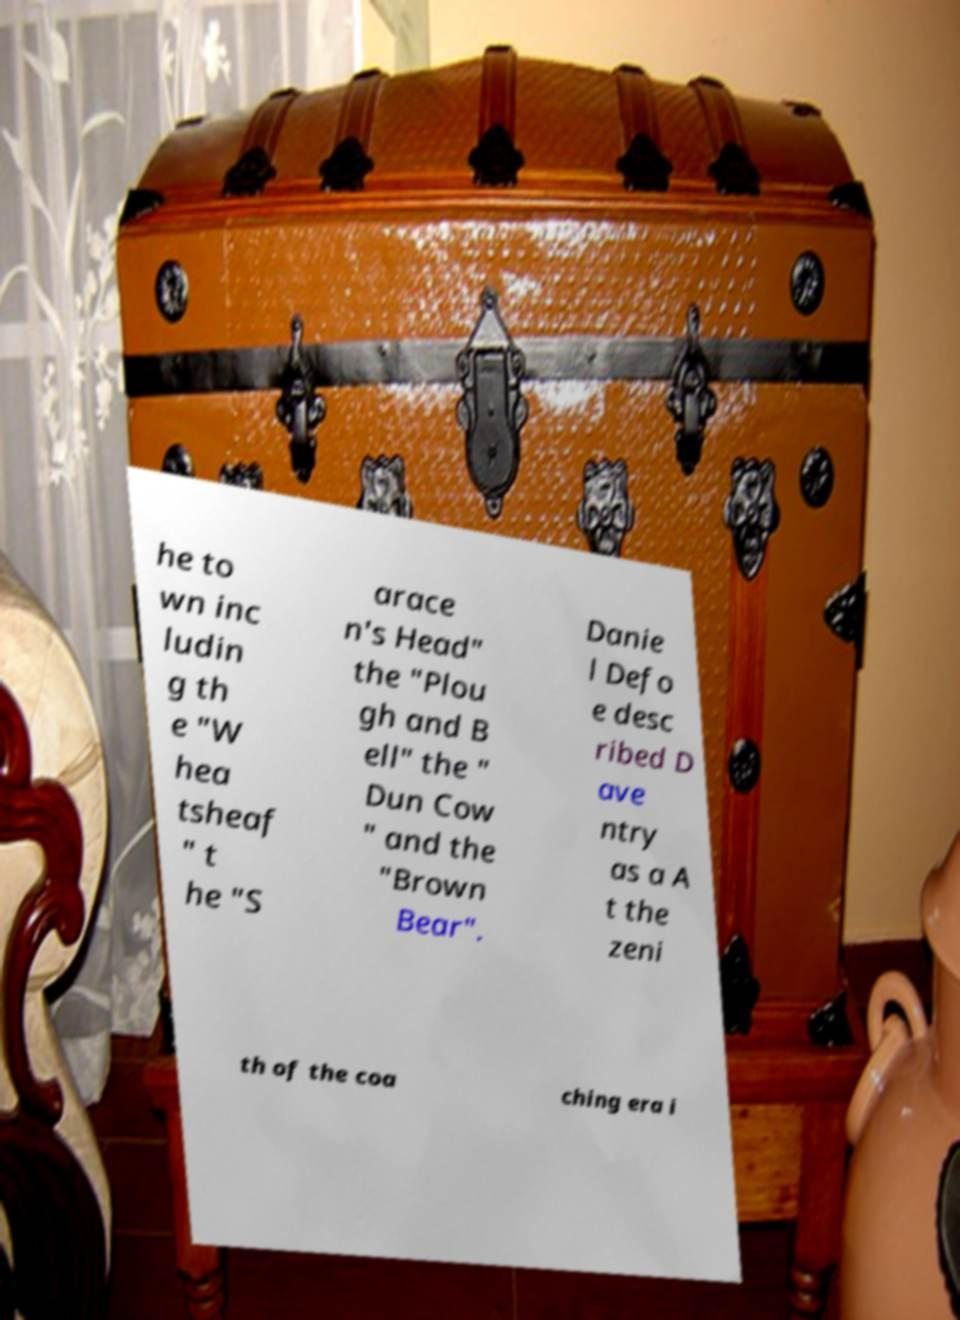I need the written content from this picture converted into text. Can you do that? he to wn inc ludin g th e "W hea tsheaf " t he "S arace n's Head" the "Plou gh and B ell" the " Dun Cow " and the "Brown Bear". Danie l Defo e desc ribed D ave ntry as a A t the zeni th of the coa ching era i 